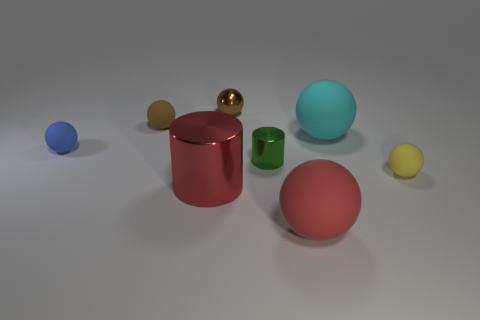What is the shape of the big rubber thing that is the same color as the large metal cylinder?
Your answer should be very brief. Sphere. Is the number of brown matte objects that are in front of the small green object less than the number of blue things?
Offer a very short reply. Yes. Do the red metallic object and the tiny green shiny object have the same shape?
Your answer should be compact. Yes. There is a brown ball that is made of the same material as the red ball; what size is it?
Offer a very short reply. Small. Are there fewer brown matte spheres than tiny rubber objects?
Give a very brief answer. Yes. What number of large objects are cyan objects or blue cubes?
Make the answer very short. 1. What number of big objects are both in front of the small yellow thing and behind the big red matte sphere?
Offer a terse response. 1. Are there more small brown objects than small matte objects?
Ensure brevity in your answer.  No. How many other things are the same shape as the small brown metal thing?
Make the answer very short. 5. Is the color of the metallic ball the same as the big cylinder?
Your answer should be compact. No. 